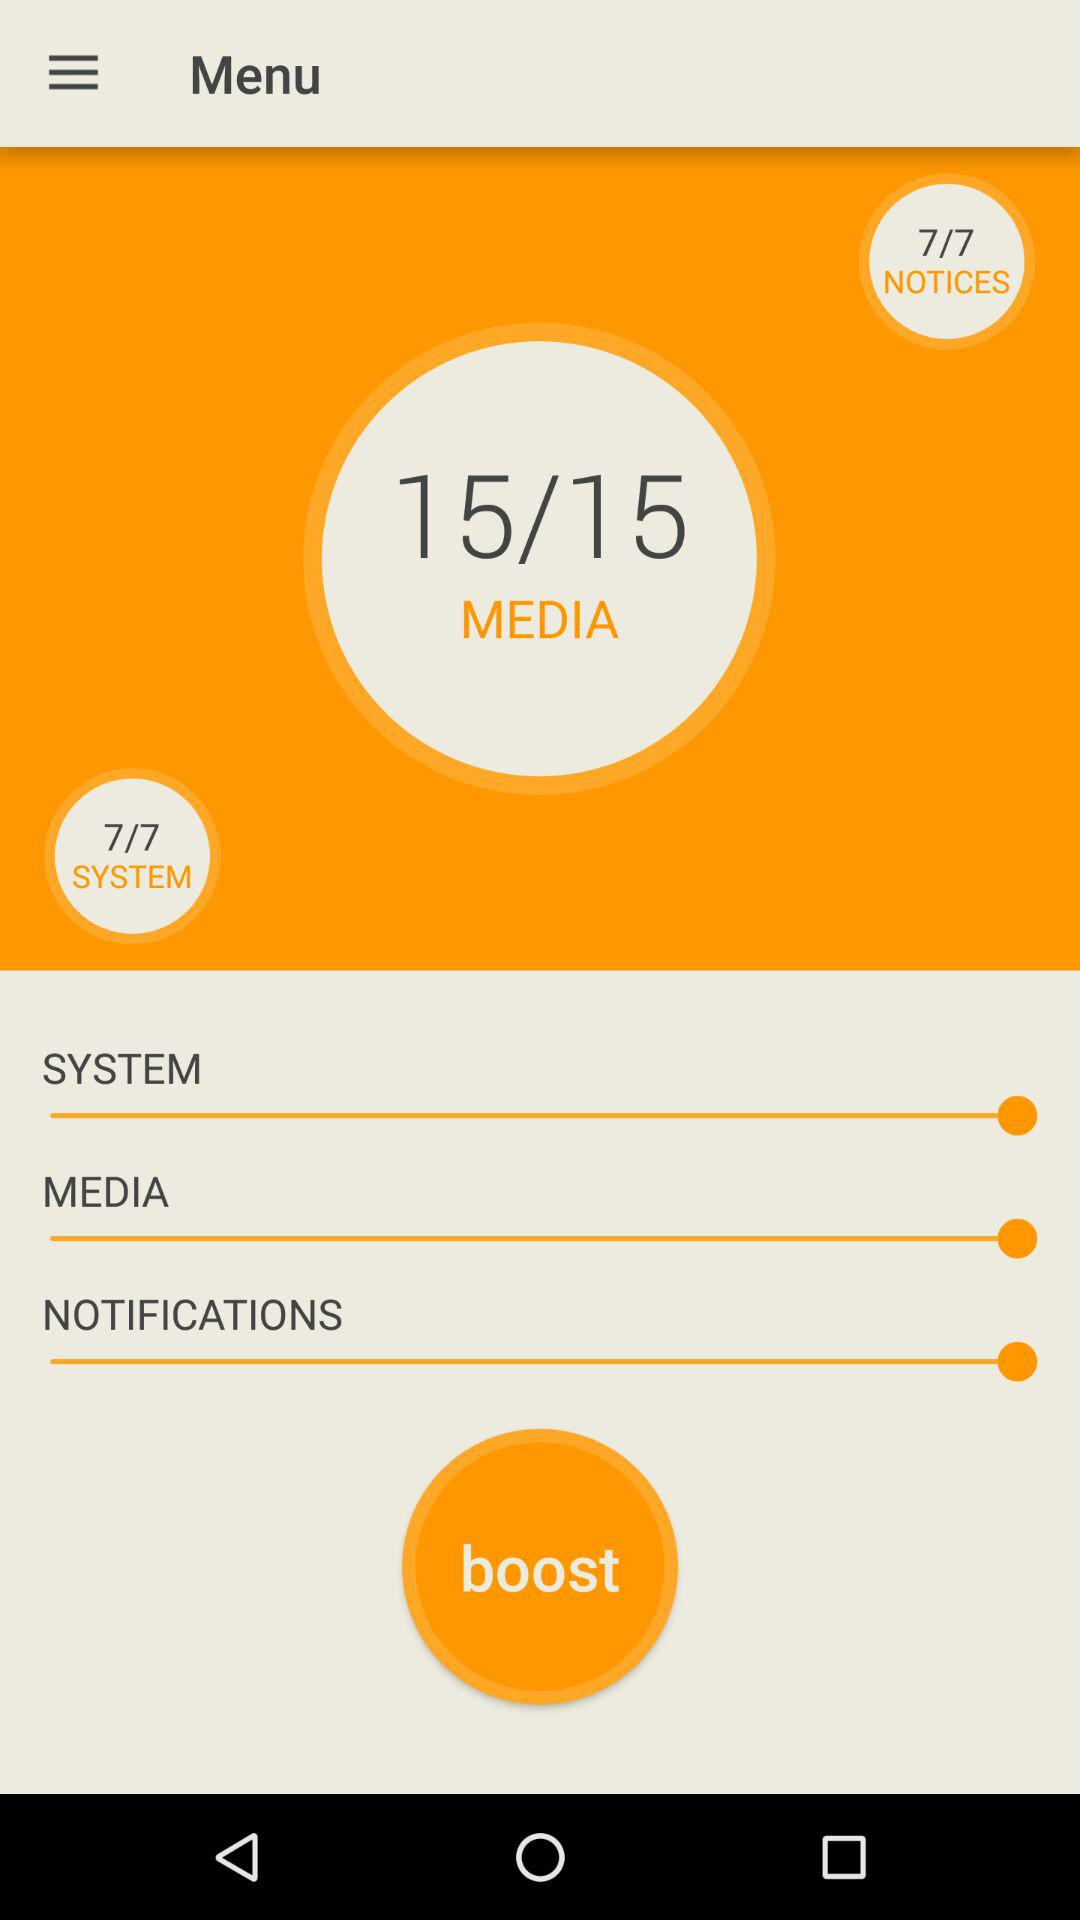How many volume levels are there for the media? There are 15 volume levels for the media. 